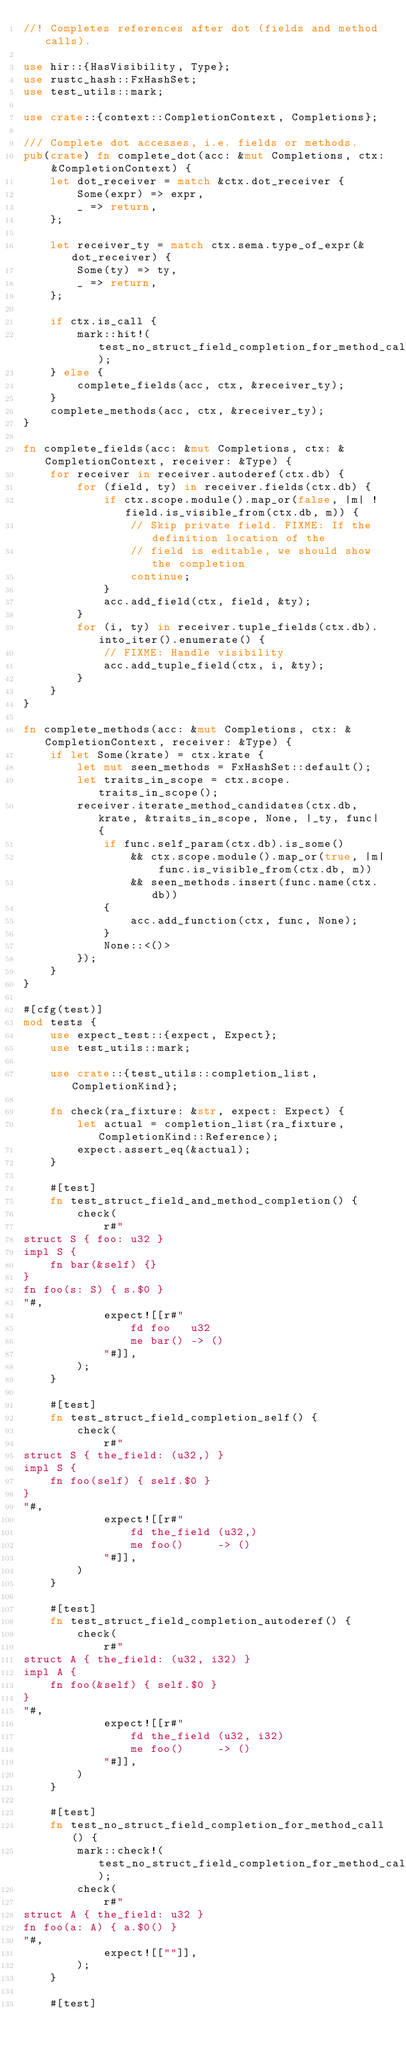Convert code to text. <code><loc_0><loc_0><loc_500><loc_500><_Rust_>//! Completes references after dot (fields and method calls).

use hir::{HasVisibility, Type};
use rustc_hash::FxHashSet;
use test_utils::mark;

use crate::{context::CompletionContext, Completions};

/// Complete dot accesses, i.e. fields or methods.
pub(crate) fn complete_dot(acc: &mut Completions, ctx: &CompletionContext) {
    let dot_receiver = match &ctx.dot_receiver {
        Some(expr) => expr,
        _ => return,
    };

    let receiver_ty = match ctx.sema.type_of_expr(&dot_receiver) {
        Some(ty) => ty,
        _ => return,
    };

    if ctx.is_call {
        mark::hit!(test_no_struct_field_completion_for_method_call);
    } else {
        complete_fields(acc, ctx, &receiver_ty);
    }
    complete_methods(acc, ctx, &receiver_ty);
}

fn complete_fields(acc: &mut Completions, ctx: &CompletionContext, receiver: &Type) {
    for receiver in receiver.autoderef(ctx.db) {
        for (field, ty) in receiver.fields(ctx.db) {
            if ctx.scope.module().map_or(false, |m| !field.is_visible_from(ctx.db, m)) {
                // Skip private field. FIXME: If the definition location of the
                // field is editable, we should show the completion
                continue;
            }
            acc.add_field(ctx, field, &ty);
        }
        for (i, ty) in receiver.tuple_fields(ctx.db).into_iter().enumerate() {
            // FIXME: Handle visibility
            acc.add_tuple_field(ctx, i, &ty);
        }
    }
}

fn complete_methods(acc: &mut Completions, ctx: &CompletionContext, receiver: &Type) {
    if let Some(krate) = ctx.krate {
        let mut seen_methods = FxHashSet::default();
        let traits_in_scope = ctx.scope.traits_in_scope();
        receiver.iterate_method_candidates(ctx.db, krate, &traits_in_scope, None, |_ty, func| {
            if func.self_param(ctx.db).is_some()
                && ctx.scope.module().map_or(true, |m| func.is_visible_from(ctx.db, m))
                && seen_methods.insert(func.name(ctx.db))
            {
                acc.add_function(ctx, func, None);
            }
            None::<()>
        });
    }
}

#[cfg(test)]
mod tests {
    use expect_test::{expect, Expect};
    use test_utils::mark;

    use crate::{test_utils::completion_list, CompletionKind};

    fn check(ra_fixture: &str, expect: Expect) {
        let actual = completion_list(ra_fixture, CompletionKind::Reference);
        expect.assert_eq(&actual);
    }

    #[test]
    fn test_struct_field_and_method_completion() {
        check(
            r#"
struct S { foo: u32 }
impl S {
    fn bar(&self) {}
}
fn foo(s: S) { s.$0 }
"#,
            expect![[r#"
                fd foo   u32
                me bar() -> ()
            "#]],
        );
    }

    #[test]
    fn test_struct_field_completion_self() {
        check(
            r#"
struct S { the_field: (u32,) }
impl S {
    fn foo(self) { self.$0 }
}
"#,
            expect![[r#"
                fd the_field (u32,)
                me foo()     -> ()
            "#]],
        )
    }

    #[test]
    fn test_struct_field_completion_autoderef() {
        check(
            r#"
struct A { the_field: (u32, i32) }
impl A {
    fn foo(&self) { self.$0 }
}
"#,
            expect![[r#"
                fd the_field (u32, i32)
                me foo()     -> ()
            "#]],
        )
    }

    #[test]
    fn test_no_struct_field_completion_for_method_call() {
        mark::check!(test_no_struct_field_completion_for_method_call);
        check(
            r#"
struct A { the_field: u32 }
fn foo(a: A) { a.$0() }
"#,
            expect![[""]],
        );
    }

    #[test]</code> 